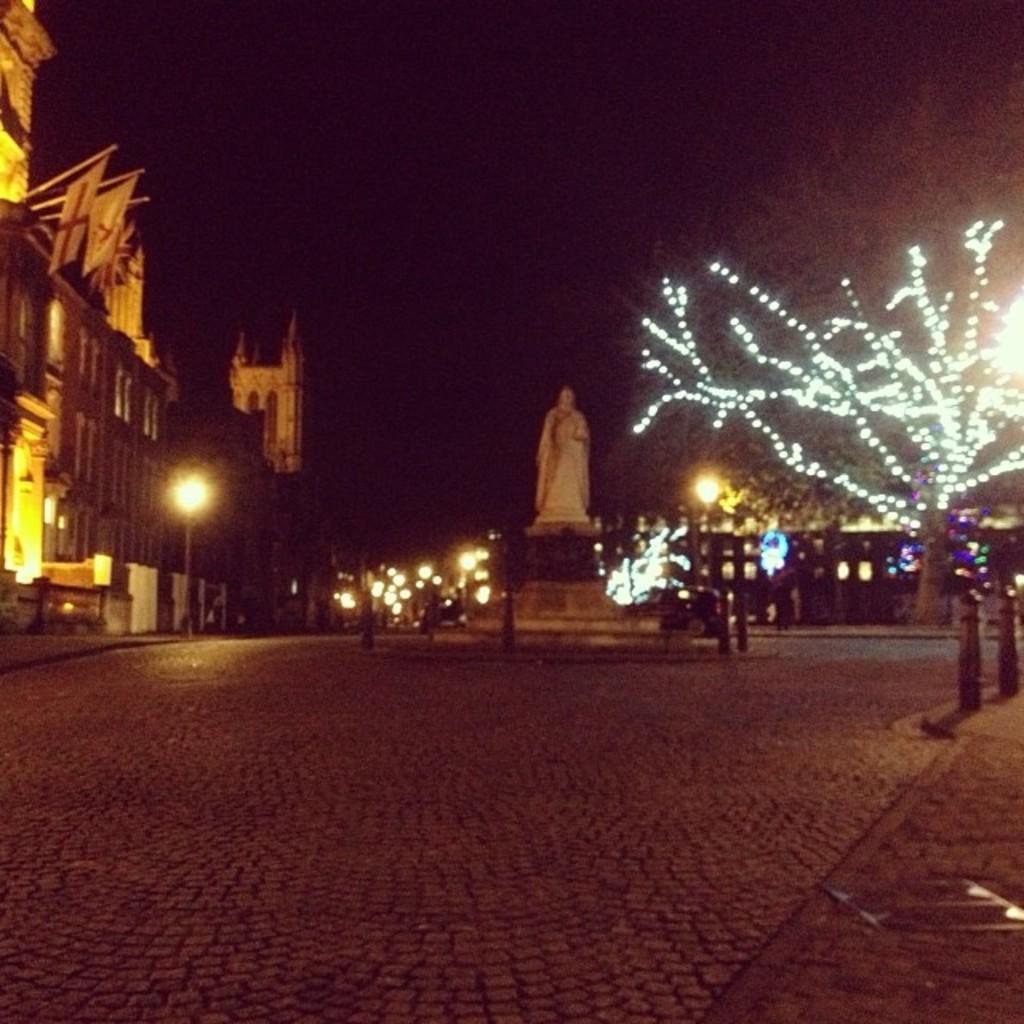Describe this image in one or two sentences. In this picture I can observe a building on the left side. In the middle of the picture I can observe a statue. On the right side there are some lights on the tree. The background is completely dark. 